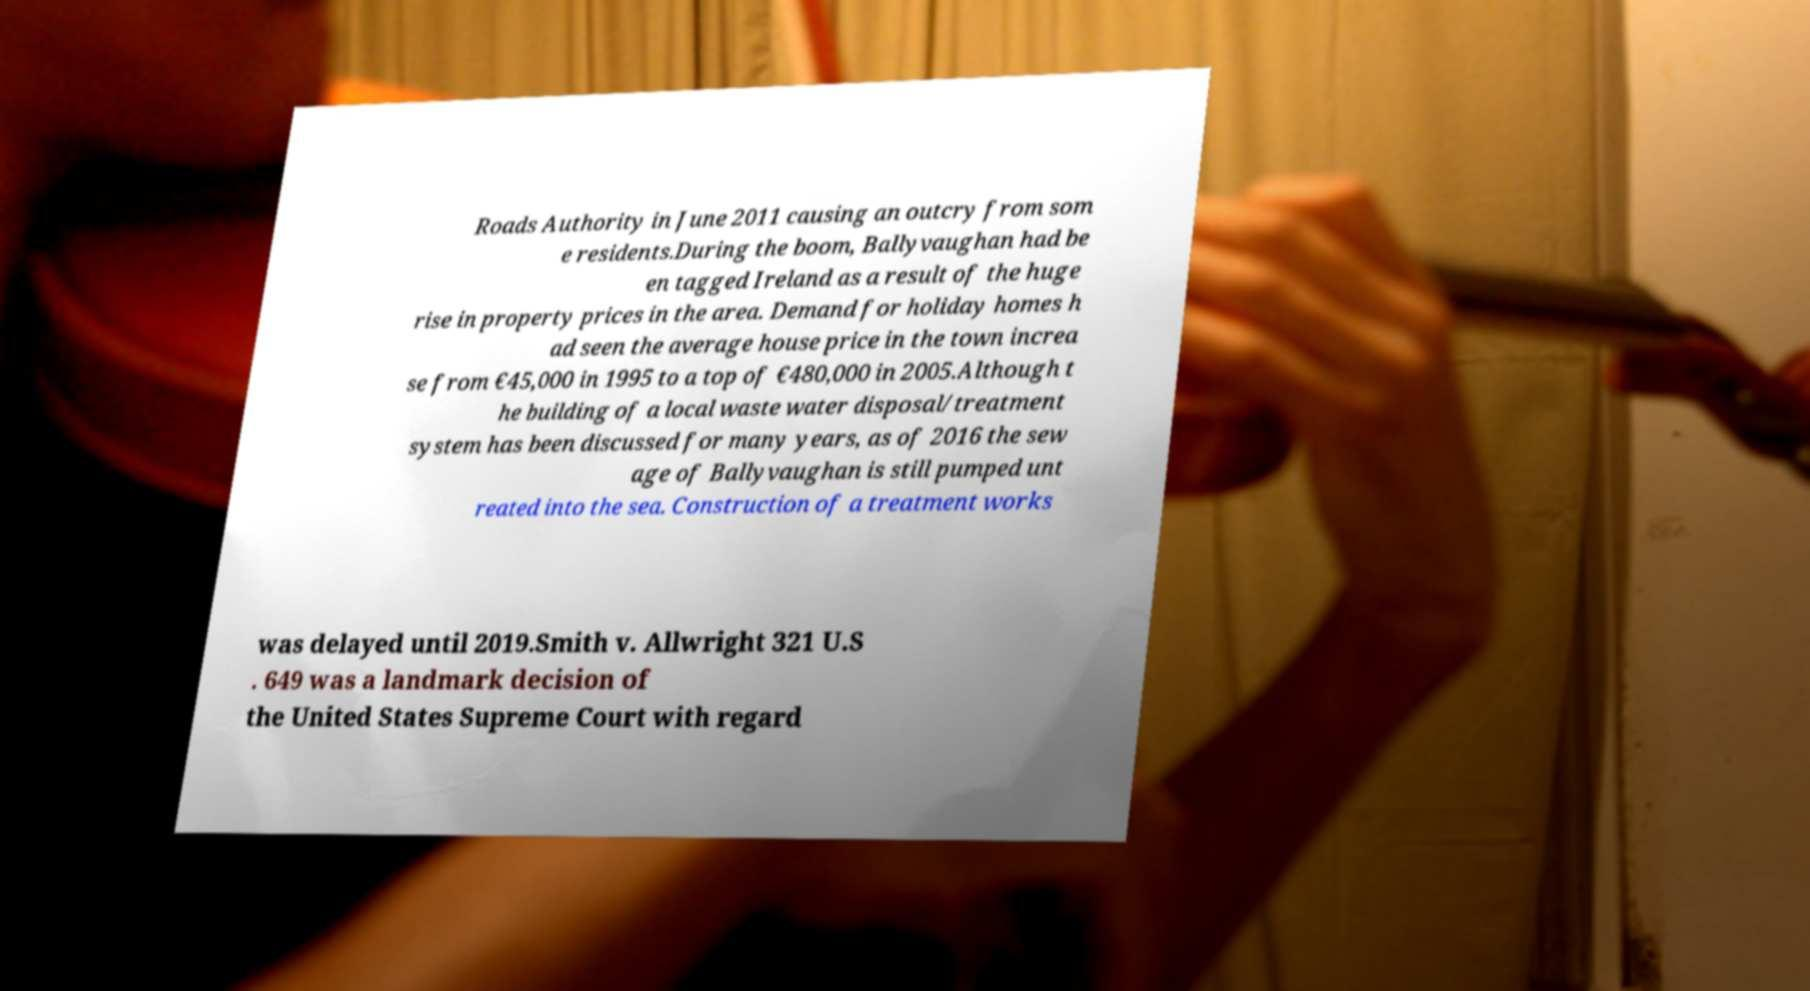Please read and relay the text visible in this image. What does it say? Roads Authority in June 2011 causing an outcry from som e residents.During the boom, Ballyvaughan had be en tagged Ireland as a result of the huge rise in property prices in the area. Demand for holiday homes h ad seen the average house price in the town increa se from €45,000 in 1995 to a top of €480,000 in 2005.Although t he building of a local waste water disposal/treatment system has been discussed for many years, as of 2016 the sew age of Ballyvaughan is still pumped unt reated into the sea. Construction of a treatment works was delayed until 2019.Smith v. Allwright 321 U.S . 649 was a landmark decision of the United States Supreme Court with regard 